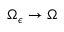Convert formula to latex. <formula><loc_0><loc_0><loc_500><loc_500>\Omega _ { \epsilon } \rightarrow \Omega</formula> 